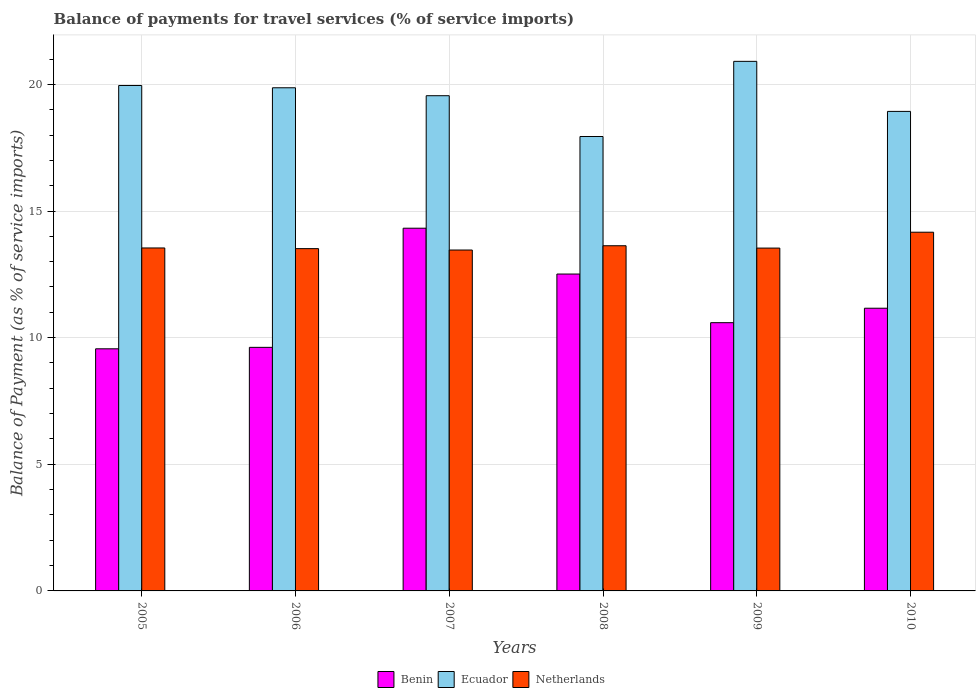How many different coloured bars are there?
Ensure brevity in your answer.  3. Are the number of bars per tick equal to the number of legend labels?
Make the answer very short. Yes. Are the number of bars on each tick of the X-axis equal?
Your answer should be very brief. Yes. How many bars are there on the 1st tick from the left?
Keep it short and to the point. 3. In how many cases, is the number of bars for a given year not equal to the number of legend labels?
Your response must be concise. 0. What is the balance of payments for travel services in Netherlands in 2009?
Your answer should be compact. 13.54. Across all years, what is the maximum balance of payments for travel services in Benin?
Offer a very short reply. 14.32. Across all years, what is the minimum balance of payments for travel services in Benin?
Keep it short and to the point. 9.56. In which year was the balance of payments for travel services in Ecuador maximum?
Provide a succinct answer. 2009. What is the total balance of payments for travel services in Benin in the graph?
Keep it short and to the point. 67.76. What is the difference between the balance of payments for travel services in Benin in 2005 and that in 2006?
Your response must be concise. -0.06. What is the difference between the balance of payments for travel services in Benin in 2009 and the balance of payments for travel services in Netherlands in 2006?
Your response must be concise. -2.92. What is the average balance of payments for travel services in Ecuador per year?
Offer a very short reply. 19.53. In the year 2008, what is the difference between the balance of payments for travel services in Benin and balance of payments for travel services in Netherlands?
Provide a succinct answer. -1.12. What is the ratio of the balance of payments for travel services in Ecuador in 2008 to that in 2010?
Offer a terse response. 0.95. Is the balance of payments for travel services in Ecuador in 2006 less than that in 2008?
Give a very brief answer. No. Is the difference between the balance of payments for travel services in Benin in 2005 and 2006 greater than the difference between the balance of payments for travel services in Netherlands in 2005 and 2006?
Make the answer very short. No. What is the difference between the highest and the second highest balance of payments for travel services in Netherlands?
Provide a short and direct response. 0.53. What is the difference between the highest and the lowest balance of payments for travel services in Netherlands?
Provide a short and direct response. 0.7. In how many years, is the balance of payments for travel services in Benin greater than the average balance of payments for travel services in Benin taken over all years?
Offer a very short reply. 2. Is the sum of the balance of payments for travel services in Ecuador in 2006 and 2010 greater than the maximum balance of payments for travel services in Netherlands across all years?
Give a very brief answer. Yes. What does the 1st bar from the left in 2006 represents?
Give a very brief answer. Benin. What does the 3rd bar from the right in 2005 represents?
Provide a short and direct response. Benin. Is it the case that in every year, the sum of the balance of payments for travel services in Netherlands and balance of payments for travel services in Benin is greater than the balance of payments for travel services in Ecuador?
Provide a succinct answer. Yes. How many bars are there?
Make the answer very short. 18. What is the difference between two consecutive major ticks on the Y-axis?
Your answer should be compact. 5. Are the values on the major ticks of Y-axis written in scientific E-notation?
Provide a succinct answer. No. Does the graph contain any zero values?
Give a very brief answer. No. How many legend labels are there?
Your answer should be compact. 3. How are the legend labels stacked?
Provide a succinct answer. Horizontal. What is the title of the graph?
Offer a very short reply. Balance of payments for travel services (% of service imports). Does "Burkina Faso" appear as one of the legend labels in the graph?
Your answer should be compact. No. What is the label or title of the X-axis?
Your answer should be very brief. Years. What is the label or title of the Y-axis?
Make the answer very short. Balance of Payment (as % of service imports). What is the Balance of Payment (as % of service imports) in Benin in 2005?
Offer a terse response. 9.56. What is the Balance of Payment (as % of service imports) of Ecuador in 2005?
Offer a very short reply. 19.96. What is the Balance of Payment (as % of service imports) in Netherlands in 2005?
Offer a very short reply. 13.54. What is the Balance of Payment (as % of service imports) of Benin in 2006?
Make the answer very short. 9.62. What is the Balance of Payment (as % of service imports) of Ecuador in 2006?
Keep it short and to the point. 19.87. What is the Balance of Payment (as % of service imports) of Netherlands in 2006?
Your answer should be compact. 13.51. What is the Balance of Payment (as % of service imports) in Benin in 2007?
Make the answer very short. 14.32. What is the Balance of Payment (as % of service imports) in Ecuador in 2007?
Keep it short and to the point. 19.55. What is the Balance of Payment (as % of service imports) of Netherlands in 2007?
Give a very brief answer. 13.46. What is the Balance of Payment (as % of service imports) of Benin in 2008?
Keep it short and to the point. 12.51. What is the Balance of Payment (as % of service imports) in Ecuador in 2008?
Offer a very short reply. 17.94. What is the Balance of Payment (as % of service imports) of Netherlands in 2008?
Provide a succinct answer. 13.63. What is the Balance of Payment (as % of service imports) in Benin in 2009?
Provide a short and direct response. 10.59. What is the Balance of Payment (as % of service imports) of Ecuador in 2009?
Ensure brevity in your answer.  20.91. What is the Balance of Payment (as % of service imports) in Netherlands in 2009?
Offer a terse response. 13.54. What is the Balance of Payment (as % of service imports) of Benin in 2010?
Give a very brief answer. 11.16. What is the Balance of Payment (as % of service imports) in Ecuador in 2010?
Give a very brief answer. 18.93. What is the Balance of Payment (as % of service imports) of Netherlands in 2010?
Offer a terse response. 14.16. Across all years, what is the maximum Balance of Payment (as % of service imports) in Benin?
Give a very brief answer. 14.32. Across all years, what is the maximum Balance of Payment (as % of service imports) in Ecuador?
Make the answer very short. 20.91. Across all years, what is the maximum Balance of Payment (as % of service imports) in Netherlands?
Make the answer very short. 14.16. Across all years, what is the minimum Balance of Payment (as % of service imports) of Benin?
Ensure brevity in your answer.  9.56. Across all years, what is the minimum Balance of Payment (as % of service imports) of Ecuador?
Ensure brevity in your answer.  17.94. Across all years, what is the minimum Balance of Payment (as % of service imports) of Netherlands?
Your answer should be compact. 13.46. What is the total Balance of Payment (as % of service imports) of Benin in the graph?
Your answer should be compact. 67.76. What is the total Balance of Payment (as % of service imports) in Ecuador in the graph?
Give a very brief answer. 117.15. What is the total Balance of Payment (as % of service imports) of Netherlands in the graph?
Offer a terse response. 81.84. What is the difference between the Balance of Payment (as % of service imports) of Benin in 2005 and that in 2006?
Ensure brevity in your answer.  -0.06. What is the difference between the Balance of Payment (as % of service imports) of Ecuador in 2005 and that in 2006?
Give a very brief answer. 0.09. What is the difference between the Balance of Payment (as % of service imports) in Netherlands in 2005 and that in 2006?
Keep it short and to the point. 0.03. What is the difference between the Balance of Payment (as % of service imports) of Benin in 2005 and that in 2007?
Ensure brevity in your answer.  -4.76. What is the difference between the Balance of Payment (as % of service imports) in Ecuador in 2005 and that in 2007?
Give a very brief answer. 0.4. What is the difference between the Balance of Payment (as % of service imports) in Netherlands in 2005 and that in 2007?
Your answer should be compact. 0.08. What is the difference between the Balance of Payment (as % of service imports) of Benin in 2005 and that in 2008?
Your answer should be very brief. -2.95. What is the difference between the Balance of Payment (as % of service imports) of Ecuador in 2005 and that in 2008?
Your response must be concise. 2.01. What is the difference between the Balance of Payment (as % of service imports) of Netherlands in 2005 and that in 2008?
Ensure brevity in your answer.  -0.09. What is the difference between the Balance of Payment (as % of service imports) in Benin in 2005 and that in 2009?
Ensure brevity in your answer.  -1.03. What is the difference between the Balance of Payment (as % of service imports) in Ecuador in 2005 and that in 2009?
Provide a short and direct response. -0.95. What is the difference between the Balance of Payment (as % of service imports) in Netherlands in 2005 and that in 2009?
Make the answer very short. 0. What is the difference between the Balance of Payment (as % of service imports) in Benin in 2005 and that in 2010?
Your answer should be very brief. -1.6. What is the difference between the Balance of Payment (as % of service imports) in Netherlands in 2005 and that in 2010?
Your answer should be compact. -0.62. What is the difference between the Balance of Payment (as % of service imports) in Benin in 2006 and that in 2007?
Offer a terse response. -4.7. What is the difference between the Balance of Payment (as % of service imports) in Ecuador in 2006 and that in 2007?
Give a very brief answer. 0.31. What is the difference between the Balance of Payment (as % of service imports) in Netherlands in 2006 and that in 2007?
Offer a very short reply. 0.06. What is the difference between the Balance of Payment (as % of service imports) of Benin in 2006 and that in 2008?
Offer a very short reply. -2.89. What is the difference between the Balance of Payment (as % of service imports) in Ecuador in 2006 and that in 2008?
Make the answer very short. 1.92. What is the difference between the Balance of Payment (as % of service imports) of Netherlands in 2006 and that in 2008?
Offer a very short reply. -0.11. What is the difference between the Balance of Payment (as % of service imports) in Benin in 2006 and that in 2009?
Keep it short and to the point. -0.97. What is the difference between the Balance of Payment (as % of service imports) in Ecuador in 2006 and that in 2009?
Provide a short and direct response. -1.04. What is the difference between the Balance of Payment (as % of service imports) in Netherlands in 2006 and that in 2009?
Keep it short and to the point. -0.02. What is the difference between the Balance of Payment (as % of service imports) in Benin in 2006 and that in 2010?
Provide a short and direct response. -1.54. What is the difference between the Balance of Payment (as % of service imports) of Ecuador in 2006 and that in 2010?
Your response must be concise. 0.93. What is the difference between the Balance of Payment (as % of service imports) in Netherlands in 2006 and that in 2010?
Make the answer very short. -0.65. What is the difference between the Balance of Payment (as % of service imports) in Benin in 2007 and that in 2008?
Your answer should be compact. 1.81. What is the difference between the Balance of Payment (as % of service imports) in Ecuador in 2007 and that in 2008?
Offer a terse response. 1.61. What is the difference between the Balance of Payment (as % of service imports) of Netherlands in 2007 and that in 2008?
Keep it short and to the point. -0.17. What is the difference between the Balance of Payment (as % of service imports) of Benin in 2007 and that in 2009?
Ensure brevity in your answer.  3.73. What is the difference between the Balance of Payment (as % of service imports) of Ecuador in 2007 and that in 2009?
Your response must be concise. -1.36. What is the difference between the Balance of Payment (as % of service imports) in Netherlands in 2007 and that in 2009?
Keep it short and to the point. -0.08. What is the difference between the Balance of Payment (as % of service imports) in Benin in 2007 and that in 2010?
Ensure brevity in your answer.  3.16. What is the difference between the Balance of Payment (as % of service imports) of Ecuador in 2007 and that in 2010?
Keep it short and to the point. 0.62. What is the difference between the Balance of Payment (as % of service imports) in Netherlands in 2007 and that in 2010?
Make the answer very short. -0.7. What is the difference between the Balance of Payment (as % of service imports) of Benin in 2008 and that in 2009?
Ensure brevity in your answer.  1.92. What is the difference between the Balance of Payment (as % of service imports) in Ecuador in 2008 and that in 2009?
Provide a short and direct response. -2.97. What is the difference between the Balance of Payment (as % of service imports) in Netherlands in 2008 and that in 2009?
Your answer should be compact. 0.09. What is the difference between the Balance of Payment (as % of service imports) in Benin in 2008 and that in 2010?
Your response must be concise. 1.35. What is the difference between the Balance of Payment (as % of service imports) in Ecuador in 2008 and that in 2010?
Your response must be concise. -0.99. What is the difference between the Balance of Payment (as % of service imports) in Netherlands in 2008 and that in 2010?
Your answer should be compact. -0.53. What is the difference between the Balance of Payment (as % of service imports) of Benin in 2009 and that in 2010?
Offer a very short reply. -0.57. What is the difference between the Balance of Payment (as % of service imports) in Ecuador in 2009 and that in 2010?
Provide a short and direct response. 1.98. What is the difference between the Balance of Payment (as % of service imports) in Netherlands in 2009 and that in 2010?
Your response must be concise. -0.63. What is the difference between the Balance of Payment (as % of service imports) of Benin in 2005 and the Balance of Payment (as % of service imports) of Ecuador in 2006?
Make the answer very short. -10.31. What is the difference between the Balance of Payment (as % of service imports) in Benin in 2005 and the Balance of Payment (as % of service imports) in Netherlands in 2006?
Give a very brief answer. -3.96. What is the difference between the Balance of Payment (as % of service imports) in Ecuador in 2005 and the Balance of Payment (as % of service imports) in Netherlands in 2006?
Your answer should be very brief. 6.44. What is the difference between the Balance of Payment (as % of service imports) in Benin in 2005 and the Balance of Payment (as % of service imports) in Ecuador in 2007?
Provide a succinct answer. -9.99. What is the difference between the Balance of Payment (as % of service imports) in Benin in 2005 and the Balance of Payment (as % of service imports) in Netherlands in 2007?
Offer a terse response. -3.9. What is the difference between the Balance of Payment (as % of service imports) of Ecuador in 2005 and the Balance of Payment (as % of service imports) of Netherlands in 2007?
Ensure brevity in your answer.  6.5. What is the difference between the Balance of Payment (as % of service imports) of Benin in 2005 and the Balance of Payment (as % of service imports) of Ecuador in 2008?
Your response must be concise. -8.38. What is the difference between the Balance of Payment (as % of service imports) of Benin in 2005 and the Balance of Payment (as % of service imports) of Netherlands in 2008?
Your answer should be very brief. -4.07. What is the difference between the Balance of Payment (as % of service imports) of Ecuador in 2005 and the Balance of Payment (as % of service imports) of Netherlands in 2008?
Keep it short and to the point. 6.33. What is the difference between the Balance of Payment (as % of service imports) in Benin in 2005 and the Balance of Payment (as % of service imports) in Ecuador in 2009?
Give a very brief answer. -11.35. What is the difference between the Balance of Payment (as % of service imports) in Benin in 2005 and the Balance of Payment (as % of service imports) in Netherlands in 2009?
Make the answer very short. -3.98. What is the difference between the Balance of Payment (as % of service imports) in Ecuador in 2005 and the Balance of Payment (as % of service imports) in Netherlands in 2009?
Give a very brief answer. 6.42. What is the difference between the Balance of Payment (as % of service imports) of Benin in 2005 and the Balance of Payment (as % of service imports) of Ecuador in 2010?
Provide a short and direct response. -9.37. What is the difference between the Balance of Payment (as % of service imports) of Benin in 2005 and the Balance of Payment (as % of service imports) of Netherlands in 2010?
Make the answer very short. -4.6. What is the difference between the Balance of Payment (as % of service imports) of Ecuador in 2005 and the Balance of Payment (as % of service imports) of Netherlands in 2010?
Your response must be concise. 5.79. What is the difference between the Balance of Payment (as % of service imports) of Benin in 2006 and the Balance of Payment (as % of service imports) of Ecuador in 2007?
Provide a succinct answer. -9.94. What is the difference between the Balance of Payment (as % of service imports) in Benin in 2006 and the Balance of Payment (as % of service imports) in Netherlands in 2007?
Make the answer very short. -3.84. What is the difference between the Balance of Payment (as % of service imports) in Ecuador in 2006 and the Balance of Payment (as % of service imports) in Netherlands in 2007?
Your answer should be very brief. 6.41. What is the difference between the Balance of Payment (as % of service imports) in Benin in 2006 and the Balance of Payment (as % of service imports) in Ecuador in 2008?
Provide a succinct answer. -8.32. What is the difference between the Balance of Payment (as % of service imports) of Benin in 2006 and the Balance of Payment (as % of service imports) of Netherlands in 2008?
Ensure brevity in your answer.  -4.01. What is the difference between the Balance of Payment (as % of service imports) of Ecuador in 2006 and the Balance of Payment (as % of service imports) of Netherlands in 2008?
Your answer should be compact. 6.24. What is the difference between the Balance of Payment (as % of service imports) of Benin in 2006 and the Balance of Payment (as % of service imports) of Ecuador in 2009?
Your answer should be compact. -11.29. What is the difference between the Balance of Payment (as % of service imports) of Benin in 2006 and the Balance of Payment (as % of service imports) of Netherlands in 2009?
Make the answer very short. -3.92. What is the difference between the Balance of Payment (as % of service imports) of Ecuador in 2006 and the Balance of Payment (as % of service imports) of Netherlands in 2009?
Your answer should be compact. 6.33. What is the difference between the Balance of Payment (as % of service imports) of Benin in 2006 and the Balance of Payment (as % of service imports) of Ecuador in 2010?
Ensure brevity in your answer.  -9.32. What is the difference between the Balance of Payment (as % of service imports) in Benin in 2006 and the Balance of Payment (as % of service imports) in Netherlands in 2010?
Offer a very short reply. -4.55. What is the difference between the Balance of Payment (as % of service imports) of Ecuador in 2006 and the Balance of Payment (as % of service imports) of Netherlands in 2010?
Make the answer very short. 5.7. What is the difference between the Balance of Payment (as % of service imports) in Benin in 2007 and the Balance of Payment (as % of service imports) in Ecuador in 2008?
Your answer should be compact. -3.62. What is the difference between the Balance of Payment (as % of service imports) in Benin in 2007 and the Balance of Payment (as % of service imports) in Netherlands in 2008?
Offer a very short reply. 0.69. What is the difference between the Balance of Payment (as % of service imports) of Ecuador in 2007 and the Balance of Payment (as % of service imports) of Netherlands in 2008?
Give a very brief answer. 5.92. What is the difference between the Balance of Payment (as % of service imports) in Benin in 2007 and the Balance of Payment (as % of service imports) in Ecuador in 2009?
Ensure brevity in your answer.  -6.59. What is the difference between the Balance of Payment (as % of service imports) of Benin in 2007 and the Balance of Payment (as % of service imports) of Netherlands in 2009?
Your answer should be compact. 0.78. What is the difference between the Balance of Payment (as % of service imports) of Ecuador in 2007 and the Balance of Payment (as % of service imports) of Netherlands in 2009?
Offer a very short reply. 6.02. What is the difference between the Balance of Payment (as % of service imports) in Benin in 2007 and the Balance of Payment (as % of service imports) in Ecuador in 2010?
Provide a succinct answer. -4.61. What is the difference between the Balance of Payment (as % of service imports) in Benin in 2007 and the Balance of Payment (as % of service imports) in Netherlands in 2010?
Ensure brevity in your answer.  0.16. What is the difference between the Balance of Payment (as % of service imports) in Ecuador in 2007 and the Balance of Payment (as % of service imports) in Netherlands in 2010?
Ensure brevity in your answer.  5.39. What is the difference between the Balance of Payment (as % of service imports) in Benin in 2008 and the Balance of Payment (as % of service imports) in Ecuador in 2009?
Give a very brief answer. -8.4. What is the difference between the Balance of Payment (as % of service imports) of Benin in 2008 and the Balance of Payment (as % of service imports) of Netherlands in 2009?
Offer a terse response. -1.03. What is the difference between the Balance of Payment (as % of service imports) of Ecuador in 2008 and the Balance of Payment (as % of service imports) of Netherlands in 2009?
Your response must be concise. 4.4. What is the difference between the Balance of Payment (as % of service imports) in Benin in 2008 and the Balance of Payment (as % of service imports) in Ecuador in 2010?
Give a very brief answer. -6.42. What is the difference between the Balance of Payment (as % of service imports) of Benin in 2008 and the Balance of Payment (as % of service imports) of Netherlands in 2010?
Your answer should be compact. -1.65. What is the difference between the Balance of Payment (as % of service imports) in Ecuador in 2008 and the Balance of Payment (as % of service imports) in Netherlands in 2010?
Keep it short and to the point. 3.78. What is the difference between the Balance of Payment (as % of service imports) in Benin in 2009 and the Balance of Payment (as % of service imports) in Ecuador in 2010?
Keep it short and to the point. -8.34. What is the difference between the Balance of Payment (as % of service imports) of Benin in 2009 and the Balance of Payment (as % of service imports) of Netherlands in 2010?
Ensure brevity in your answer.  -3.57. What is the difference between the Balance of Payment (as % of service imports) in Ecuador in 2009 and the Balance of Payment (as % of service imports) in Netherlands in 2010?
Offer a terse response. 6.75. What is the average Balance of Payment (as % of service imports) in Benin per year?
Your answer should be very brief. 11.29. What is the average Balance of Payment (as % of service imports) in Ecuador per year?
Offer a very short reply. 19.53. What is the average Balance of Payment (as % of service imports) of Netherlands per year?
Offer a terse response. 13.64. In the year 2005, what is the difference between the Balance of Payment (as % of service imports) of Benin and Balance of Payment (as % of service imports) of Ecuador?
Offer a terse response. -10.4. In the year 2005, what is the difference between the Balance of Payment (as % of service imports) in Benin and Balance of Payment (as % of service imports) in Netherlands?
Make the answer very short. -3.98. In the year 2005, what is the difference between the Balance of Payment (as % of service imports) in Ecuador and Balance of Payment (as % of service imports) in Netherlands?
Provide a short and direct response. 6.41. In the year 2006, what is the difference between the Balance of Payment (as % of service imports) of Benin and Balance of Payment (as % of service imports) of Ecuador?
Your answer should be very brief. -10.25. In the year 2006, what is the difference between the Balance of Payment (as % of service imports) in Benin and Balance of Payment (as % of service imports) in Netherlands?
Ensure brevity in your answer.  -3.9. In the year 2006, what is the difference between the Balance of Payment (as % of service imports) of Ecuador and Balance of Payment (as % of service imports) of Netherlands?
Ensure brevity in your answer.  6.35. In the year 2007, what is the difference between the Balance of Payment (as % of service imports) in Benin and Balance of Payment (as % of service imports) in Ecuador?
Offer a terse response. -5.23. In the year 2007, what is the difference between the Balance of Payment (as % of service imports) of Benin and Balance of Payment (as % of service imports) of Netherlands?
Give a very brief answer. 0.86. In the year 2007, what is the difference between the Balance of Payment (as % of service imports) in Ecuador and Balance of Payment (as % of service imports) in Netherlands?
Keep it short and to the point. 6.09. In the year 2008, what is the difference between the Balance of Payment (as % of service imports) of Benin and Balance of Payment (as % of service imports) of Ecuador?
Make the answer very short. -5.43. In the year 2008, what is the difference between the Balance of Payment (as % of service imports) in Benin and Balance of Payment (as % of service imports) in Netherlands?
Your answer should be compact. -1.12. In the year 2008, what is the difference between the Balance of Payment (as % of service imports) of Ecuador and Balance of Payment (as % of service imports) of Netherlands?
Offer a terse response. 4.31. In the year 2009, what is the difference between the Balance of Payment (as % of service imports) in Benin and Balance of Payment (as % of service imports) in Ecuador?
Offer a terse response. -10.32. In the year 2009, what is the difference between the Balance of Payment (as % of service imports) of Benin and Balance of Payment (as % of service imports) of Netherlands?
Give a very brief answer. -2.95. In the year 2009, what is the difference between the Balance of Payment (as % of service imports) of Ecuador and Balance of Payment (as % of service imports) of Netherlands?
Your answer should be very brief. 7.37. In the year 2010, what is the difference between the Balance of Payment (as % of service imports) of Benin and Balance of Payment (as % of service imports) of Ecuador?
Offer a very short reply. -7.77. In the year 2010, what is the difference between the Balance of Payment (as % of service imports) of Benin and Balance of Payment (as % of service imports) of Netherlands?
Make the answer very short. -3. In the year 2010, what is the difference between the Balance of Payment (as % of service imports) of Ecuador and Balance of Payment (as % of service imports) of Netherlands?
Offer a terse response. 4.77. What is the ratio of the Balance of Payment (as % of service imports) in Netherlands in 2005 to that in 2006?
Keep it short and to the point. 1. What is the ratio of the Balance of Payment (as % of service imports) in Benin in 2005 to that in 2007?
Offer a terse response. 0.67. What is the ratio of the Balance of Payment (as % of service imports) in Ecuador in 2005 to that in 2007?
Provide a succinct answer. 1.02. What is the ratio of the Balance of Payment (as % of service imports) of Benin in 2005 to that in 2008?
Provide a succinct answer. 0.76. What is the ratio of the Balance of Payment (as % of service imports) in Ecuador in 2005 to that in 2008?
Provide a succinct answer. 1.11. What is the ratio of the Balance of Payment (as % of service imports) of Netherlands in 2005 to that in 2008?
Give a very brief answer. 0.99. What is the ratio of the Balance of Payment (as % of service imports) in Benin in 2005 to that in 2009?
Offer a very short reply. 0.9. What is the ratio of the Balance of Payment (as % of service imports) of Ecuador in 2005 to that in 2009?
Your response must be concise. 0.95. What is the ratio of the Balance of Payment (as % of service imports) of Netherlands in 2005 to that in 2009?
Provide a succinct answer. 1. What is the ratio of the Balance of Payment (as % of service imports) of Benin in 2005 to that in 2010?
Your answer should be very brief. 0.86. What is the ratio of the Balance of Payment (as % of service imports) in Ecuador in 2005 to that in 2010?
Your answer should be compact. 1.05. What is the ratio of the Balance of Payment (as % of service imports) of Netherlands in 2005 to that in 2010?
Offer a very short reply. 0.96. What is the ratio of the Balance of Payment (as % of service imports) of Benin in 2006 to that in 2007?
Provide a short and direct response. 0.67. What is the ratio of the Balance of Payment (as % of service imports) of Ecuador in 2006 to that in 2007?
Give a very brief answer. 1.02. What is the ratio of the Balance of Payment (as % of service imports) in Netherlands in 2006 to that in 2007?
Keep it short and to the point. 1. What is the ratio of the Balance of Payment (as % of service imports) in Benin in 2006 to that in 2008?
Provide a short and direct response. 0.77. What is the ratio of the Balance of Payment (as % of service imports) in Ecuador in 2006 to that in 2008?
Your response must be concise. 1.11. What is the ratio of the Balance of Payment (as % of service imports) of Netherlands in 2006 to that in 2008?
Offer a terse response. 0.99. What is the ratio of the Balance of Payment (as % of service imports) of Benin in 2006 to that in 2009?
Offer a very short reply. 0.91. What is the ratio of the Balance of Payment (as % of service imports) of Ecuador in 2006 to that in 2009?
Keep it short and to the point. 0.95. What is the ratio of the Balance of Payment (as % of service imports) of Benin in 2006 to that in 2010?
Your answer should be compact. 0.86. What is the ratio of the Balance of Payment (as % of service imports) of Ecuador in 2006 to that in 2010?
Provide a short and direct response. 1.05. What is the ratio of the Balance of Payment (as % of service imports) in Netherlands in 2006 to that in 2010?
Your response must be concise. 0.95. What is the ratio of the Balance of Payment (as % of service imports) of Benin in 2007 to that in 2008?
Your response must be concise. 1.14. What is the ratio of the Balance of Payment (as % of service imports) of Ecuador in 2007 to that in 2008?
Make the answer very short. 1.09. What is the ratio of the Balance of Payment (as % of service imports) of Netherlands in 2007 to that in 2008?
Offer a terse response. 0.99. What is the ratio of the Balance of Payment (as % of service imports) in Benin in 2007 to that in 2009?
Give a very brief answer. 1.35. What is the ratio of the Balance of Payment (as % of service imports) in Ecuador in 2007 to that in 2009?
Your answer should be compact. 0.94. What is the ratio of the Balance of Payment (as % of service imports) in Netherlands in 2007 to that in 2009?
Offer a terse response. 0.99. What is the ratio of the Balance of Payment (as % of service imports) in Benin in 2007 to that in 2010?
Provide a short and direct response. 1.28. What is the ratio of the Balance of Payment (as % of service imports) in Ecuador in 2007 to that in 2010?
Your answer should be very brief. 1.03. What is the ratio of the Balance of Payment (as % of service imports) in Netherlands in 2007 to that in 2010?
Offer a very short reply. 0.95. What is the ratio of the Balance of Payment (as % of service imports) of Benin in 2008 to that in 2009?
Provide a succinct answer. 1.18. What is the ratio of the Balance of Payment (as % of service imports) in Ecuador in 2008 to that in 2009?
Keep it short and to the point. 0.86. What is the ratio of the Balance of Payment (as % of service imports) of Netherlands in 2008 to that in 2009?
Your response must be concise. 1.01. What is the ratio of the Balance of Payment (as % of service imports) in Benin in 2008 to that in 2010?
Make the answer very short. 1.12. What is the ratio of the Balance of Payment (as % of service imports) in Ecuador in 2008 to that in 2010?
Give a very brief answer. 0.95. What is the ratio of the Balance of Payment (as % of service imports) of Netherlands in 2008 to that in 2010?
Your answer should be compact. 0.96. What is the ratio of the Balance of Payment (as % of service imports) in Benin in 2009 to that in 2010?
Give a very brief answer. 0.95. What is the ratio of the Balance of Payment (as % of service imports) of Ecuador in 2009 to that in 2010?
Provide a short and direct response. 1.1. What is the ratio of the Balance of Payment (as % of service imports) in Netherlands in 2009 to that in 2010?
Your answer should be very brief. 0.96. What is the difference between the highest and the second highest Balance of Payment (as % of service imports) in Benin?
Ensure brevity in your answer.  1.81. What is the difference between the highest and the second highest Balance of Payment (as % of service imports) in Ecuador?
Provide a short and direct response. 0.95. What is the difference between the highest and the second highest Balance of Payment (as % of service imports) in Netherlands?
Offer a very short reply. 0.53. What is the difference between the highest and the lowest Balance of Payment (as % of service imports) of Benin?
Provide a short and direct response. 4.76. What is the difference between the highest and the lowest Balance of Payment (as % of service imports) of Ecuador?
Your response must be concise. 2.97. What is the difference between the highest and the lowest Balance of Payment (as % of service imports) in Netherlands?
Keep it short and to the point. 0.7. 